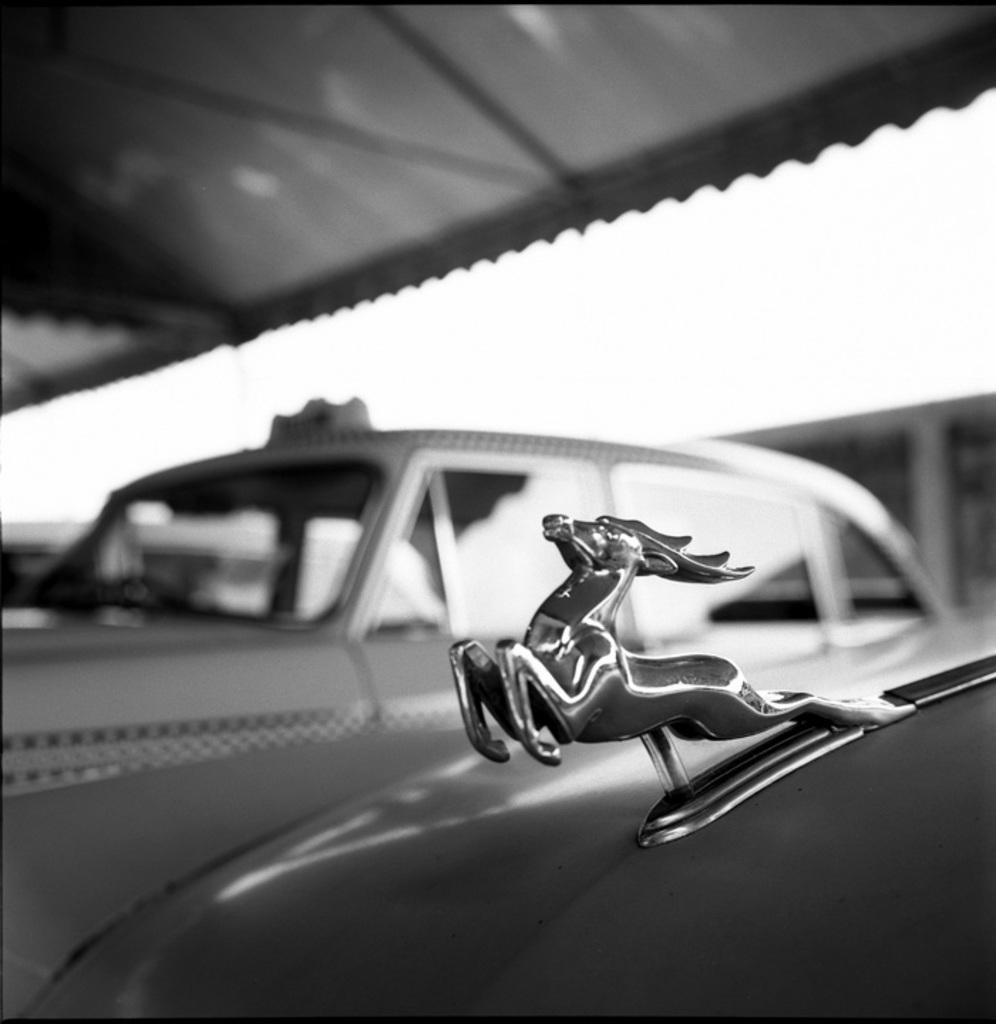Describe this image in one or two sentences. In this image I can see few cars and in the front I can see a logo on the car. I can also see this image is little bit blurry and I can see this image is black and white in colour. 